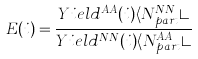<formula> <loc_0><loc_0><loc_500><loc_500>E ( i ) = \frac { Y i e l d ^ { A A } ( i ) \langle N _ { p a r t } ^ { N N } \rangle } { Y i e l d ^ { N N } ( i ) \langle N _ { p a r t } ^ { A A } \rangle }</formula> 